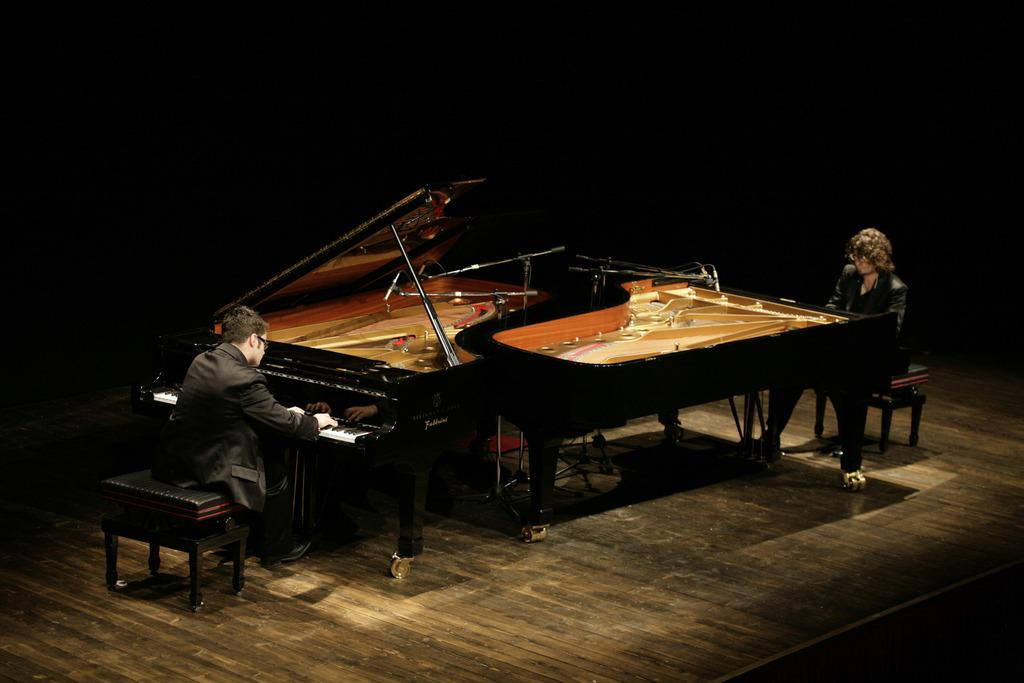How many people are in the image? There are two persons in the image. What are the two persons doing in the image? The two persons are setting and playing forte-pianos. Where does the scene appear to take place? The setting appears to be a stage. What is the color of the background in the image? The background of the image is dark. What direction is the goose facing in the image? There is no goose present in the image. What type of collar is the person on the left wearing in the image? There is no collar visible on either person in the image, as they are wearing long-sleeved clothing. 